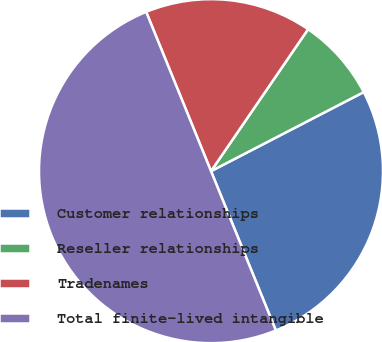Convert chart. <chart><loc_0><loc_0><loc_500><loc_500><pie_chart><fcel>Customer relationships<fcel>Reseller relationships<fcel>Tradenames<fcel>Total finite-lived intangible<nl><fcel>26.45%<fcel>7.85%<fcel>15.7%<fcel>50.0%<nl></chart> 